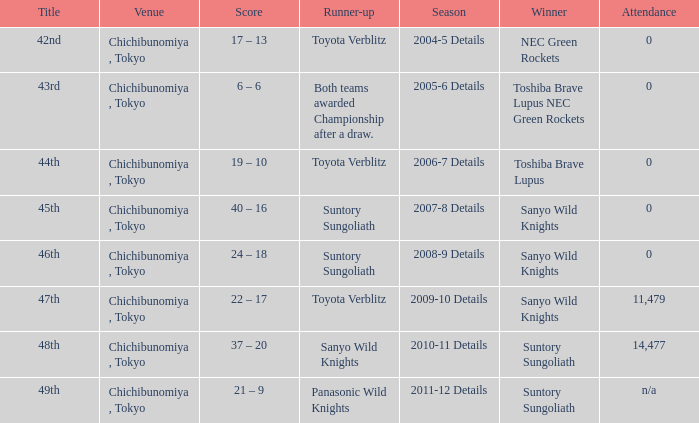What is the Attendance number when the runner-up was suntory sungoliath, and a Title of 46th? 0.0. 